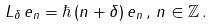Convert formula to latex. <formula><loc_0><loc_0><loc_500><loc_500>L _ { \delta } \, e _ { n } = \hbar { \, } ( n + \delta ) \, e _ { n } \, , \, n \in \mathbb { Z } \, .</formula> 